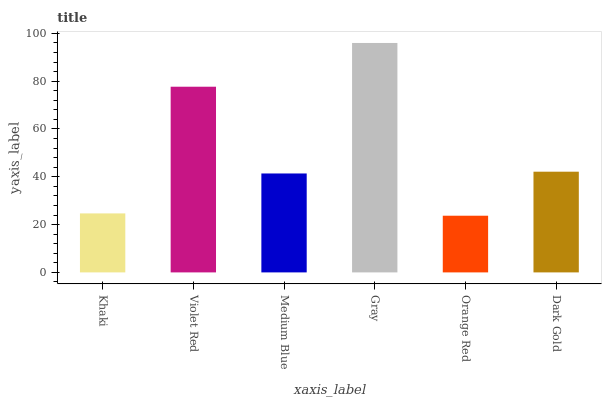Is Orange Red the minimum?
Answer yes or no. Yes. Is Gray the maximum?
Answer yes or no. Yes. Is Violet Red the minimum?
Answer yes or no. No. Is Violet Red the maximum?
Answer yes or no. No. Is Violet Red greater than Khaki?
Answer yes or no. Yes. Is Khaki less than Violet Red?
Answer yes or no. Yes. Is Khaki greater than Violet Red?
Answer yes or no. No. Is Violet Red less than Khaki?
Answer yes or no. No. Is Dark Gold the high median?
Answer yes or no. Yes. Is Medium Blue the low median?
Answer yes or no. Yes. Is Orange Red the high median?
Answer yes or no. No. Is Gray the low median?
Answer yes or no. No. 